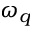<formula> <loc_0><loc_0><loc_500><loc_500>\omega _ { q }</formula> 